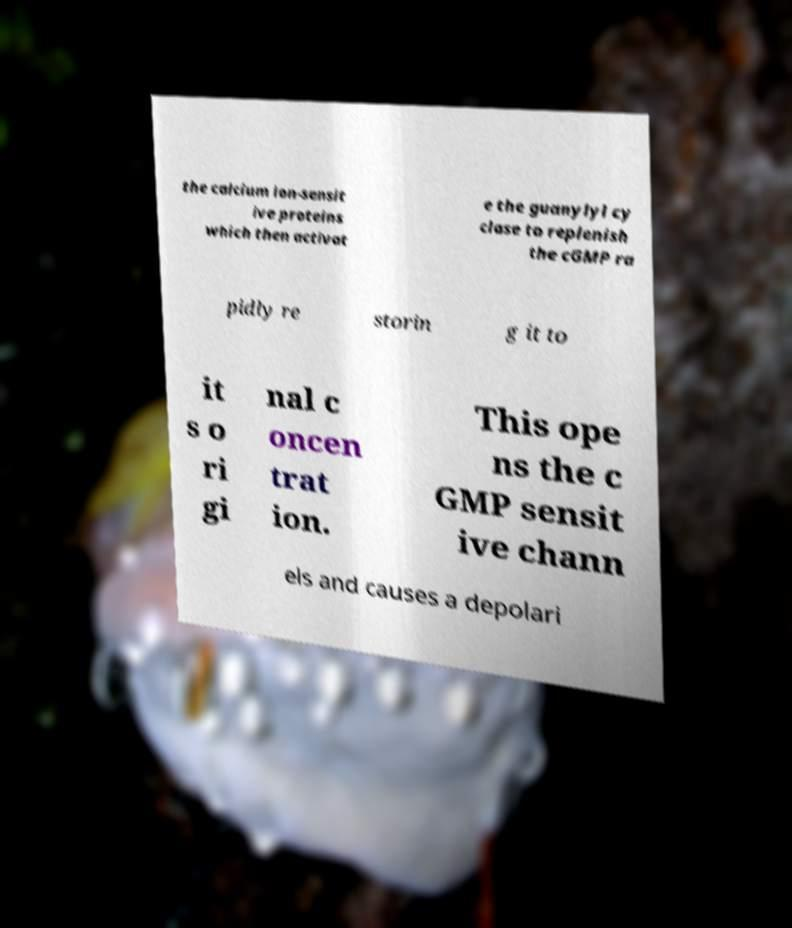Please read and relay the text visible in this image. What does it say? the calcium ion-sensit ive proteins which then activat e the guanylyl cy clase to replenish the cGMP ra pidly re storin g it to it s o ri gi nal c oncen trat ion. This ope ns the c GMP sensit ive chann els and causes a depolari 